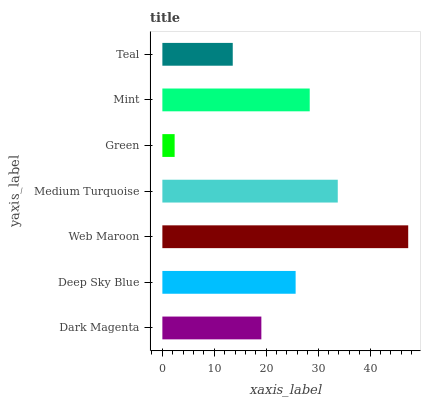Is Green the minimum?
Answer yes or no. Yes. Is Web Maroon the maximum?
Answer yes or no. Yes. Is Deep Sky Blue the minimum?
Answer yes or no. No. Is Deep Sky Blue the maximum?
Answer yes or no. No. Is Deep Sky Blue greater than Dark Magenta?
Answer yes or no. Yes. Is Dark Magenta less than Deep Sky Blue?
Answer yes or no. Yes. Is Dark Magenta greater than Deep Sky Blue?
Answer yes or no. No. Is Deep Sky Blue less than Dark Magenta?
Answer yes or no. No. Is Deep Sky Blue the high median?
Answer yes or no. Yes. Is Deep Sky Blue the low median?
Answer yes or no. Yes. Is Green the high median?
Answer yes or no. No. Is Web Maroon the low median?
Answer yes or no. No. 